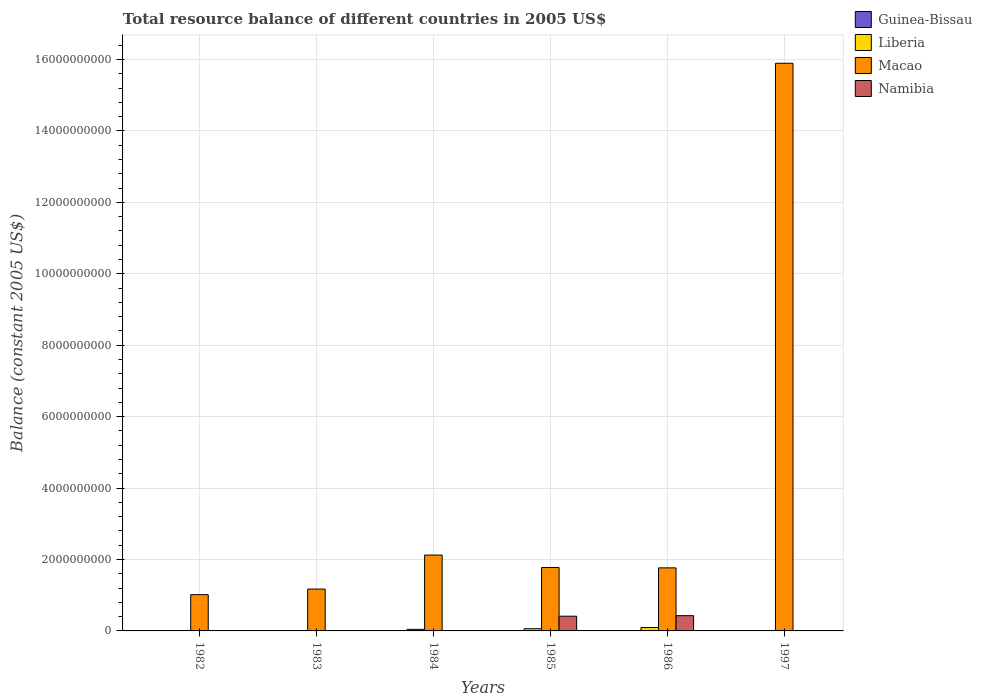How many bars are there on the 4th tick from the right?
Your answer should be very brief. 2. What is the total resource balance in Namibia in 1986?
Make the answer very short. 4.27e+08. Across all years, what is the maximum total resource balance in Liberia?
Your response must be concise. 9.50e+07. Across all years, what is the minimum total resource balance in Namibia?
Make the answer very short. 0. What is the total total resource balance in Namibia in the graph?
Keep it short and to the point. 8.39e+08. What is the difference between the total resource balance in Macao in 1982 and that in 1983?
Your answer should be very brief. -1.57e+08. What is the average total resource balance in Namibia per year?
Give a very brief answer. 1.40e+08. In the year 1984, what is the difference between the total resource balance in Macao and total resource balance in Liberia?
Make the answer very short. 2.08e+09. In how many years, is the total resource balance in Macao greater than 13600000000 US$?
Your answer should be very brief. 1. What is the ratio of the total resource balance in Macao in 1984 to that in 1986?
Give a very brief answer. 1.2. What is the difference between the highest and the second highest total resource balance in Liberia?
Provide a short and direct response. 3.30e+07. What is the difference between the highest and the lowest total resource balance in Macao?
Provide a short and direct response. 1.49e+1. In how many years, is the total resource balance in Namibia greater than the average total resource balance in Namibia taken over all years?
Make the answer very short. 2. How many bars are there?
Keep it short and to the point. 11. Are all the bars in the graph horizontal?
Provide a succinct answer. No. How many years are there in the graph?
Provide a short and direct response. 6. What is the difference between two consecutive major ticks on the Y-axis?
Your response must be concise. 2.00e+09. Does the graph contain any zero values?
Ensure brevity in your answer.  Yes. What is the title of the graph?
Make the answer very short. Total resource balance of different countries in 2005 US$. What is the label or title of the X-axis?
Offer a terse response. Years. What is the label or title of the Y-axis?
Ensure brevity in your answer.  Balance (constant 2005 US$). What is the Balance (constant 2005 US$) in Guinea-Bissau in 1982?
Your response must be concise. 0. What is the Balance (constant 2005 US$) in Macao in 1982?
Give a very brief answer. 1.02e+09. What is the Balance (constant 2005 US$) of Namibia in 1982?
Your answer should be very brief. 0. What is the Balance (constant 2005 US$) in Macao in 1983?
Keep it short and to the point. 1.17e+09. What is the Balance (constant 2005 US$) of Guinea-Bissau in 1984?
Make the answer very short. 0. What is the Balance (constant 2005 US$) in Liberia in 1984?
Offer a very short reply. 4.50e+07. What is the Balance (constant 2005 US$) in Macao in 1984?
Offer a terse response. 2.12e+09. What is the Balance (constant 2005 US$) of Liberia in 1985?
Offer a terse response. 6.20e+07. What is the Balance (constant 2005 US$) in Macao in 1985?
Your response must be concise. 1.77e+09. What is the Balance (constant 2005 US$) in Namibia in 1985?
Provide a short and direct response. 4.12e+08. What is the Balance (constant 2005 US$) in Guinea-Bissau in 1986?
Provide a succinct answer. 0. What is the Balance (constant 2005 US$) of Liberia in 1986?
Your response must be concise. 9.50e+07. What is the Balance (constant 2005 US$) in Macao in 1986?
Your answer should be compact. 1.77e+09. What is the Balance (constant 2005 US$) of Namibia in 1986?
Ensure brevity in your answer.  4.27e+08. What is the Balance (constant 2005 US$) in Macao in 1997?
Keep it short and to the point. 1.59e+1. Across all years, what is the maximum Balance (constant 2005 US$) of Liberia?
Provide a succinct answer. 9.50e+07. Across all years, what is the maximum Balance (constant 2005 US$) in Macao?
Your answer should be very brief. 1.59e+1. Across all years, what is the maximum Balance (constant 2005 US$) in Namibia?
Keep it short and to the point. 4.27e+08. Across all years, what is the minimum Balance (constant 2005 US$) in Macao?
Make the answer very short. 1.02e+09. Across all years, what is the minimum Balance (constant 2005 US$) of Namibia?
Provide a short and direct response. 0. What is the total Balance (constant 2005 US$) in Liberia in the graph?
Your response must be concise. 2.02e+08. What is the total Balance (constant 2005 US$) of Macao in the graph?
Make the answer very short. 2.37e+1. What is the total Balance (constant 2005 US$) in Namibia in the graph?
Make the answer very short. 8.39e+08. What is the difference between the Balance (constant 2005 US$) of Macao in 1982 and that in 1983?
Offer a terse response. -1.57e+08. What is the difference between the Balance (constant 2005 US$) of Macao in 1982 and that in 1984?
Ensure brevity in your answer.  -1.11e+09. What is the difference between the Balance (constant 2005 US$) in Macao in 1982 and that in 1985?
Your response must be concise. -7.59e+08. What is the difference between the Balance (constant 2005 US$) of Macao in 1982 and that in 1986?
Your answer should be very brief. -7.50e+08. What is the difference between the Balance (constant 2005 US$) of Macao in 1982 and that in 1997?
Provide a succinct answer. -1.49e+1. What is the difference between the Balance (constant 2005 US$) of Macao in 1983 and that in 1984?
Your response must be concise. -9.52e+08. What is the difference between the Balance (constant 2005 US$) in Macao in 1983 and that in 1985?
Your answer should be compact. -6.02e+08. What is the difference between the Balance (constant 2005 US$) of Macao in 1983 and that in 1986?
Your answer should be very brief. -5.93e+08. What is the difference between the Balance (constant 2005 US$) of Macao in 1983 and that in 1997?
Your answer should be very brief. -1.47e+1. What is the difference between the Balance (constant 2005 US$) of Liberia in 1984 and that in 1985?
Provide a short and direct response. -1.70e+07. What is the difference between the Balance (constant 2005 US$) of Macao in 1984 and that in 1985?
Give a very brief answer. 3.50e+08. What is the difference between the Balance (constant 2005 US$) in Liberia in 1984 and that in 1986?
Your answer should be very brief. -5.00e+07. What is the difference between the Balance (constant 2005 US$) of Macao in 1984 and that in 1986?
Make the answer very short. 3.59e+08. What is the difference between the Balance (constant 2005 US$) of Macao in 1984 and that in 1997?
Your answer should be compact. -1.38e+1. What is the difference between the Balance (constant 2005 US$) of Liberia in 1985 and that in 1986?
Offer a very short reply. -3.30e+07. What is the difference between the Balance (constant 2005 US$) of Macao in 1985 and that in 1986?
Your answer should be very brief. 8.99e+06. What is the difference between the Balance (constant 2005 US$) of Namibia in 1985 and that in 1986?
Offer a very short reply. -1.49e+07. What is the difference between the Balance (constant 2005 US$) in Macao in 1985 and that in 1997?
Your answer should be compact. -1.41e+1. What is the difference between the Balance (constant 2005 US$) of Macao in 1986 and that in 1997?
Make the answer very short. -1.41e+1. What is the difference between the Balance (constant 2005 US$) of Macao in 1982 and the Balance (constant 2005 US$) of Namibia in 1985?
Your response must be concise. 6.03e+08. What is the difference between the Balance (constant 2005 US$) in Macao in 1982 and the Balance (constant 2005 US$) in Namibia in 1986?
Your response must be concise. 5.88e+08. What is the difference between the Balance (constant 2005 US$) of Macao in 1983 and the Balance (constant 2005 US$) of Namibia in 1985?
Make the answer very short. 7.60e+08. What is the difference between the Balance (constant 2005 US$) in Macao in 1983 and the Balance (constant 2005 US$) in Namibia in 1986?
Keep it short and to the point. 7.45e+08. What is the difference between the Balance (constant 2005 US$) in Liberia in 1984 and the Balance (constant 2005 US$) in Macao in 1985?
Provide a succinct answer. -1.73e+09. What is the difference between the Balance (constant 2005 US$) of Liberia in 1984 and the Balance (constant 2005 US$) of Namibia in 1985?
Keep it short and to the point. -3.67e+08. What is the difference between the Balance (constant 2005 US$) of Macao in 1984 and the Balance (constant 2005 US$) of Namibia in 1985?
Your response must be concise. 1.71e+09. What is the difference between the Balance (constant 2005 US$) in Liberia in 1984 and the Balance (constant 2005 US$) in Macao in 1986?
Provide a succinct answer. -1.72e+09. What is the difference between the Balance (constant 2005 US$) of Liberia in 1984 and the Balance (constant 2005 US$) of Namibia in 1986?
Your answer should be very brief. -3.82e+08. What is the difference between the Balance (constant 2005 US$) in Macao in 1984 and the Balance (constant 2005 US$) in Namibia in 1986?
Provide a short and direct response. 1.70e+09. What is the difference between the Balance (constant 2005 US$) of Liberia in 1984 and the Balance (constant 2005 US$) of Macao in 1997?
Your answer should be very brief. -1.58e+1. What is the difference between the Balance (constant 2005 US$) in Liberia in 1985 and the Balance (constant 2005 US$) in Macao in 1986?
Your response must be concise. -1.70e+09. What is the difference between the Balance (constant 2005 US$) of Liberia in 1985 and the Balance (constant 2005 US$) of Namibia in 1986?
Your answer should be compact. -3.65e+08. What is the difference between the Balance (constant 2005 US$) of Macao in 1985 and the Balance (constant 2005 US$) of Namibia in 1986?
Keep it short and to the point. 1.35e+09. What is the difference between the Balance (constant 2005 US$) of Liberia in 1985 and the Balance (constant 2005 US$) of Macao in 1997?
Your answer should be very brief. -1.58e+1. What is the difference between the Balance (constant 2005 US$) of Liberia in 1986 and the Balance (constant 2005 US$) of Macao in 1997?
Give a very brief answer. -1.58e+1. What is the average Balance (constant 2005 US$) in Liberia per year?
Your answer should be very brief. 3.37e+07. What is the average Balance (constant 2005 US$) of Macao per year?
Offer a very short reply. 3.96e+09. What is the average Balance (constant 2005 US$) of Namibia per year?
Ensure brevity in your answer.  1.40e+08. In the year 1984, what is the difference between the Balance (constant 2005 US$) of Liberia and Balance (constant 2005 US$) of Macao?
Make the answer very short. -2.08e+09. In the year 1985, what is the difference between the Balance (constant 2005 US$) of Liberia and Balance (constant 2005 US$) of Macao?
Provide a succinct answer. -1.71e+09. In the year 1985, what is the difference between the Balance (constant 2005 US$) of Liberia and Balance (constant 2005 US$) of Namibia?
Offer a terse response. -3.50e+08. In the year 1985, what is the difference between the Balance (constant 2005 US$) of Macao and Balance (constant 2005 US$) of Namibia?
Your response must be concise. 1.36e+09. In the year 1986, what is the difference between the Balance (constant 2005 US$) of Liberia and Balance (constant 2005 US$) of Macao?
Give a very brief answer. -1.67e+09. In the year 1986, what is the difference between the Balance (constant 2005 US$) in Liberia and Balance (constant 2005 US$) in Namibia?
Make the answer very short. -3.32e+08. In the year 1986, what is the difference between the Balance (constant 2005 US$) in Macao and Balance (constant 2005 US$) in Namibia?
Your answer should be very brief. 1.34e+09. What is the ratio of the Balance (constant 2005 US$) of Macao in 1982 to that in 1983?
Ensure brevity in your answer.  0.87. What is the ratio of the Balance (constant 2005 US$) of Macao in 1982 to that in 1984?
Your response must be concise. 0.48. What is the ratio of the Balance (constant 2005 US$) in Macao in 1982 to that in 1985?
Ensure brevity in your answer.  0.57. What is the ratio of the Balance (constant 2005 US$) in Macao in 1982 to that in 1986?
Keep it short and to the point. 0.57. What is the ratio of the Balance (constant 2005 US$) in Macao in 1982 to that in 1997?
Provide a succinct answer. 0.06. What is the ratio of the Balance (constant 2005 US$) of Macao in 1983 to that in 1984?
Your response must be concise. 0.55. What is the ratio of the Balance (constant 2005 US$) in Macao in 1983 to that in 1985?
Your response must be concise. 0.66. What is the ratio of the Balance (constant 2005 US$) of Macao in 1983 to that in 1986?
Your answer should be compact. 0.66. What is the ratio of the Balance (constant 2005 US$) in Macao in 1983 to that in 1997?
Ensure brevity in your answer.  0.07. What is the ratio of the Balance (constant 2005 US$) of Liberia in 1984 to that in 1985?
Ensure brevity in your answer.  0.73. What is the ratio of the Balance (constant 2005 US$) of Macao in 1984 to that in 1985?
Offer a very short reply. 1.2. What is the ratio of the Balance (constant 2005 US$) in Liberia in 1984 to that in 1986?
Your answer should be compact. 0.47. What is the ratio of the Balance (constant 2005 US$) of Macao in 1984 to that in 1986?
Make the answer very short. 1.2. What is the ratio of the Balance (constant 2005 US$) of Macao in 1984 to that in 1997?
Your answer should be very brief. 0.13. What is the ratio of the Balance (constant 2005 US$) of Liberia in 1985 to that in 1986?
Provide a succinct answer. 0.65. What is the ratio of the Balance (constant 2005 US$) of Macao in 1985 to that in 1986?
Provide a succinct answer. 1.01. What is the ratio of the Balance (constant 2005 US$) in Namibia in 1985 to that in 1986?
Your answer should be compact. 0.97. What is the ratio of the Balance (constant 2005 US$) of Macao in 1985 to that in 1997?
Provide a short and direct response. 0.11. What is the difference between the highest and the second highest Balance (constant 2005 US$) in Liberia?
Make the answer very short. 3.30e+07. What is the difference between the highest and the second highest Balance (constant 2005 US$) of Macao?
Give a very brief answer. 1.38e+1. What is the difference between the highest and the lowest Balance (constant 2005 US$) of Liberia?
Offer a terse response. 9.50e+07. What is the difference between the highest and the lowest Balance (constant 2005 US$) in Macao?
Your response must be concise. 1.49e+1. What is the difference between the highest and the lowest Balance (constant 2005 US$) in Namibia?
Provide a short and direct response. 4.27e+08. 